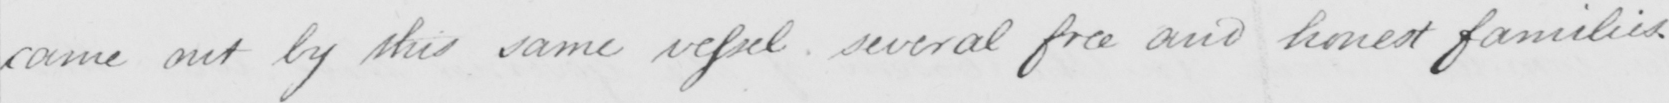What text is written in this handwritten line? came out by this same vessel several free and honest families . 